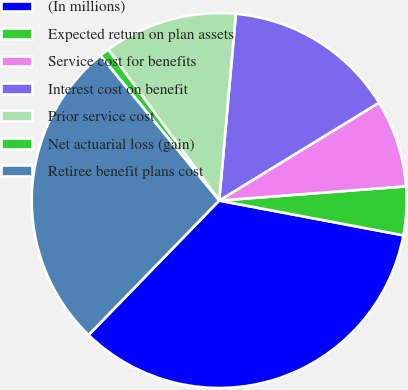<chart> <loc_0><loc_0><loc_500><loc_500><pie_chart><fcel>(In millions)<fcel>Expected return on plan assets<fcel>Service cost for benefits<fcel>Interest cost on benefit<fcel>Prior service cost<fcel>Net actuarial loss (gain)<fcel>Retiree benefit plans cost<nl><fcel>34.3%<fcel>4.18%<fcel>7.53%<fcel>14.84%<fcel>11.5%<fcel>0.84%<fcel>26.8%<nl></chart> 